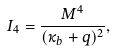Convert formula to latex. <formula><loc_0><loc_0><loc_500><loc_500>I _ { 4 } = \frac { M ^ { 4 } } { ( \kappa _ { b } + q ) ^ { 2 } } ,</formula> 